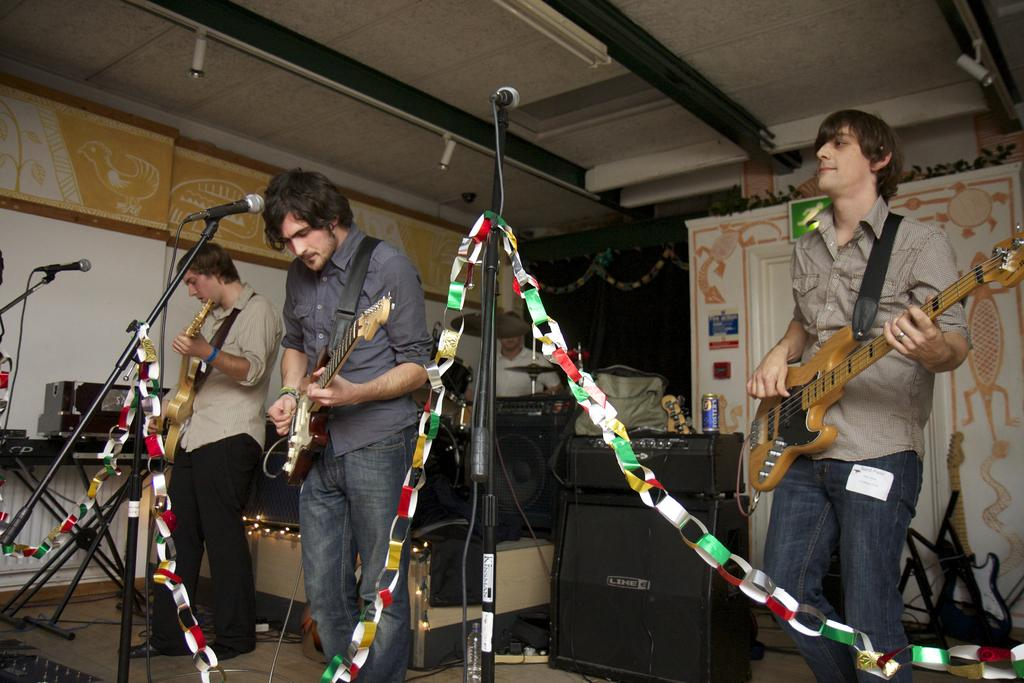Who is present in the image? There are men in the image. What are the men holding in the image? The men are holding guitars. What object is in front of the men? There is a microphone with a stand in front of the men. What type of pies are being served on the table in the image? There is no table or pies present in the image; it features men holding guitars and a microphone with a stand. 